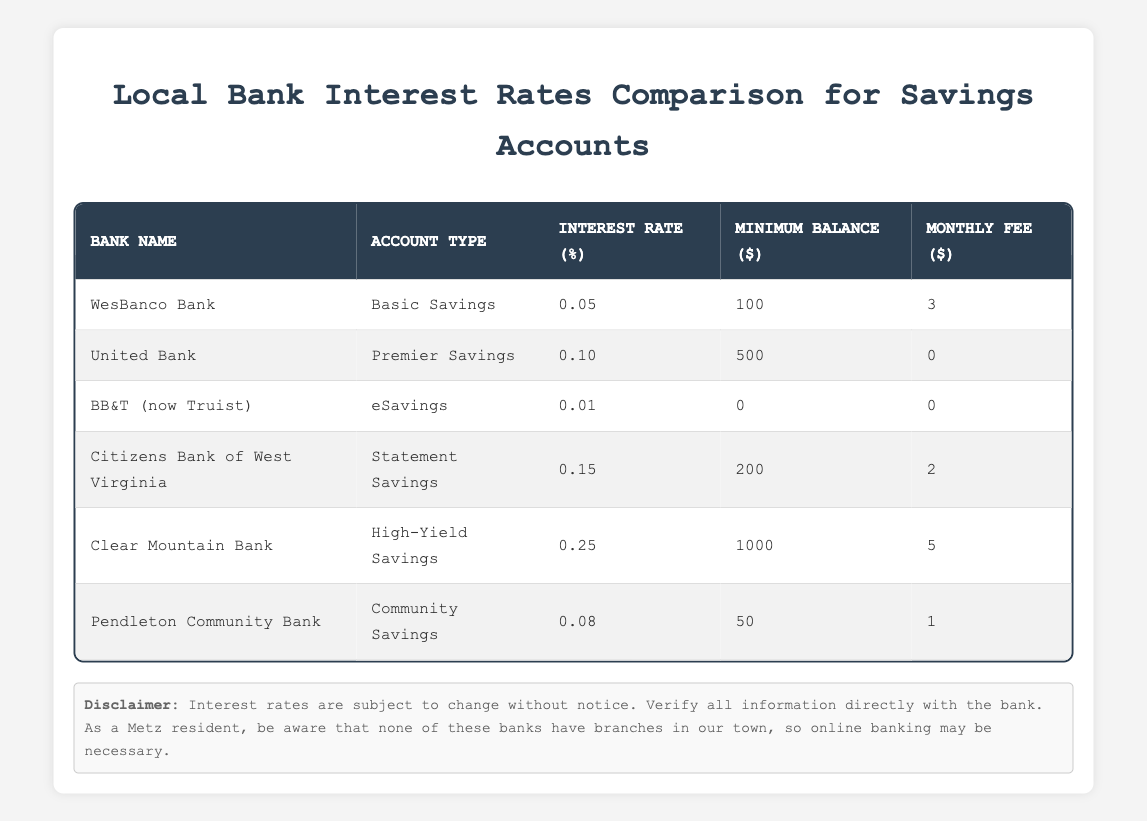What is the highest interest rate offered among the listed banks? By looking at the "Interest Rate (%)" column, the highest value is 0.25, which corresponds to Clear Mountain Bank's High-Yield Savings account.
Answer: 0.25 Which bank has no monthly fee for its savings account? In the "Monthly Fee ($)" column, I can see that United Bank and BB&T (now Truist) both have a fee of 0, indicating they do not charge a monthly fee.
Answer: United Bank and BB&T (now Truist) What is the minimum balance requirement for Citizens Bank of West Virginia? Checking the "Minimum Balance ($)" column for Citizens Bank of West Virginia shows a value of 200.
Answer: 200 Which bank offers the lowest interest rate? The "Interest Rate (%)" column reveals that BB&T (now Truist) offers the lowest rate at 0.01.
Answer: 0.01 How much higher is the interest rate of Citizens Bank of West Virginia compared to BB&T (now Truist)? I find that Citizens Bank of West Virginia has an interest rate of 0.15 and BB&T (now Truist) has 0.01. The difference is calculated as 0.15 - 0.01 = 0.14.
Answer: 0.14 Is it true that all banks listed have no branches in Metz? By referring to the "branchesInMetz" column, all values are 0, confirming that none of the banks have branches in Metz.
Answer: Yes How many banks offer a savings account with an interest rate of at least 0.1? I can count the banks with interest rates of 0.1 or higher: United Bank (0.10), Citizens Bank of West Virginia (0.15), and Clear Mountain Bank (0.25), totaling 3 banks.
Answer: 3 What is the total of minimum balance requirements across all banks? I add up the minimum balance requirements: 100 + 500 + 0 + 200 + 1000 + 50 = 1850.
Answer: 1850 If I deposit $1,000 into the High-Yield Savings account at Clear Mountain Bank, how much interest would I earn in one year? The interest rate is 0.25, so I calculate the earnings as 1,000 * 0.25 = 250. Therefore, the interest would be $250.
Answer: 250 